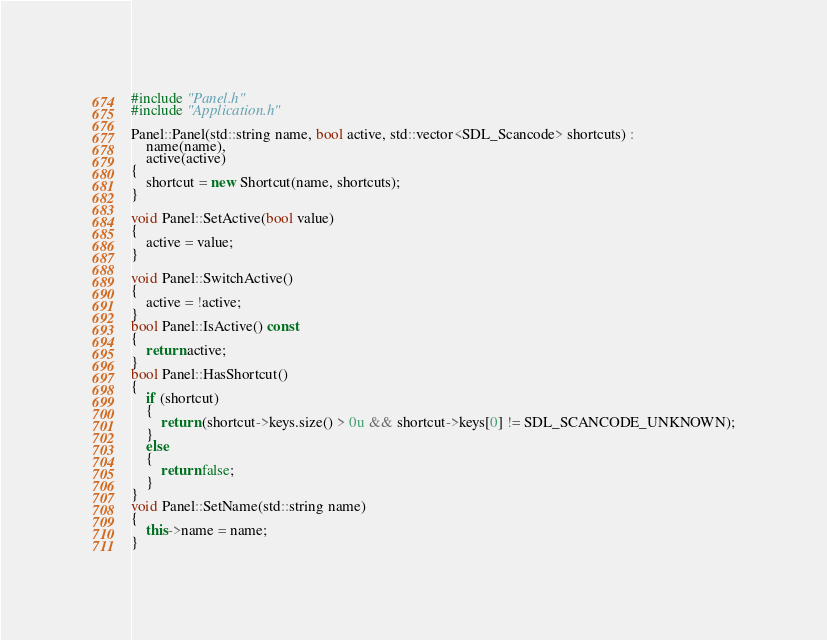<code> <loc_0><loc_0><loc_500><loc_500><_C++_>#include "Panel.h"
#include "Application.h"

Panel::Panel(std::string name, bool active, std::vector<SDL_Scancode> shortcuts) :
	name(name),
	active(active)
{
	shortcut = new Shortcut(name, shortcuts);
}

void Panel::SetActive(bool value)
{
	active = value;
}

void Panel::SwitchActive()
{
	active = !active;
}
bool Panel::IsActive() const
{
	return active;
}
bool Panel::HasShortcut()
{
	if (shortcut)
	{
		return (shortcut->keys.size() > 0u && shortcut->keys[0] != SDL_SCANCODE_UNKNOWN);
	}
	else
	{
		return false;
	}
}
void Panel::SetName(std::string name)
{
	this->name = name;
}</code> 